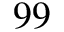<formula> <loc_0><loc_0><loc_500><loc_500>9 9</formula> 